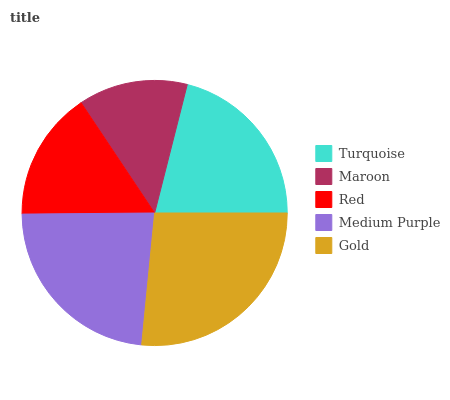Is Maroon the minimum?
Answer yes or no. Yes. Is Gold the maximum?
Answer yes or no. Yes. Is Red the minimum?
Answer yes or no. No. Is Red the maximum?
Answer yes or no. No. Is Red greater than Maroon?
Answer yes or no. Yes. Is Maroon less than Red?
Answer yes or no. Yes. Is Maroon greater than Red?
Answer yes or no. No. Is Red less than Maroon?
Answer yes or no. No. Is Turquoise the high median?
Answer yes or no. Yes. Is Turquoise the low median?
Answer yes or no. Yes. Is Red the high median?
Answer yes or no. No. Is Medium Purple the low median?
Answer yes or no. No. 